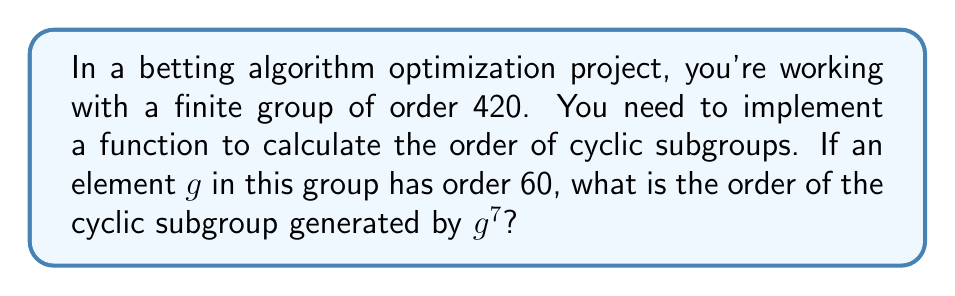What is the answer to this math problem? Let's approach this step-by-step:

1) First, recall that for an element $g$ in a group $G$, the order of $g$ is the smallest positive integer $n$ such that $g^n = e$ (the identity element).

2) We're given that the order of $g$ is 60. This means that $g^{60} = e$.

3) Now, we need to find the order of $g^7$. Let's call this order $m$.

4) By definition, $m$ is the smallest positive integer such that $(g^7)^m = e$.

5) We can rewrite this as $g^{7m} = e$.

6) From group theory, we know that $g^{7m} = e$ if and only if 60 divides $7m$. This is because 60 is the order of $g$.

7) In other words, we need to find the smallest positive integer $m$ such that:

   $$60 \mid 7m$$

8) We can solve this using the concept of least common multiple (LCM):

   $$m = \frac{\text{LCM}(60, 7)}{7}$$

9) To find LCM(60, 7):
   - Factor 60 = $2^2 \times 3 \times 5$
   - 7 is already prime
   - LCM(60, 7) = $2^2 \times 3 \times 5 \times 7 = 420$

10) Therefore:

    $$m = \frac{420}{7} = 60$$

Thus, the order of the cyclic subgroup generated by $g^7$ is 60.
Answer: 60 